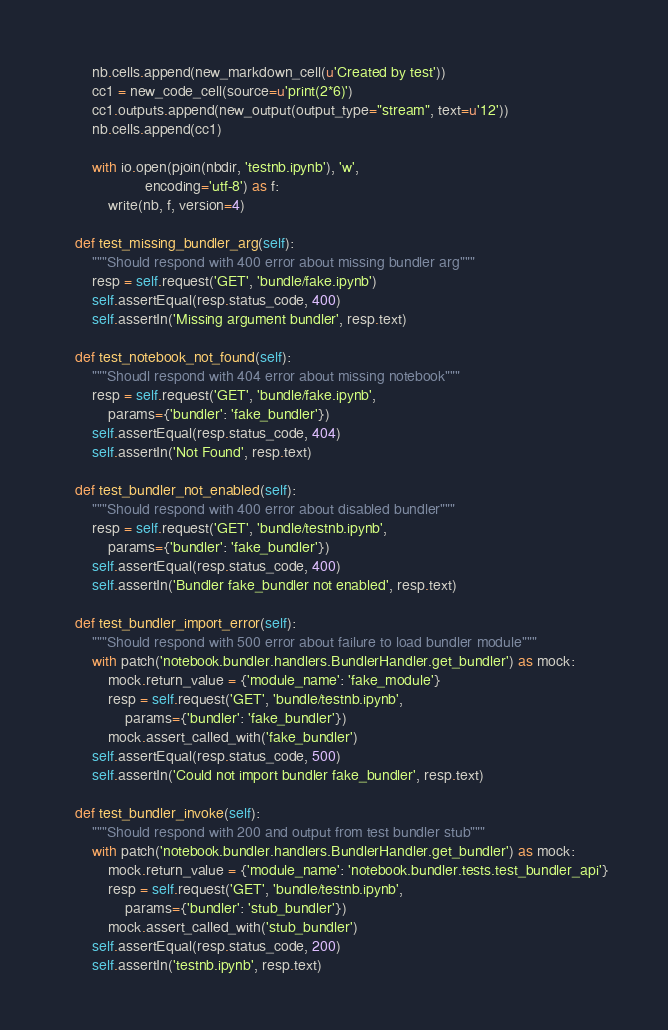Convert code to text. <code><loc_0><loc_0><loc_500><loc_500><_Python_>        nb.cells.append(new_markdown_cell(u'Created by test'))
        cc1 = new_code_cell(source=u'print(2*6)')
        cc1.outputs.append(new_output(output_type="stream", text=u'12'))
        nb.cells.append(cc1)
        
        with io.open(pjoin(nbdir, 'testnb.ipynb'), 'w',
                     encoding='utf-8') as f:
            write(nb, f, version=4)

    def test_missing_bundler_arg(self):
        """Should respond with 400 error about missing bundler arg"""
        resp = self.request('GET', 'bundle/fake.ipynb')
        self.assertEqual(resp.status_code, 400)
        self.assertIn('Missing argument bundler', resp.text)

    def test_notebook_not_found(self):
        """Shoudl respond with 404 error about missing notebook"""
        resp = self.request('GET', 'bundle/fake.ipynb',
            params={'bundler': 'fake_bundler'})
        self.assertEqual(resp.status_code, 404)
        self.assertIn('Not Found', resp.text)

    def test_bundler_not_enabled(self):
        """Should respond with 400 error about disabled bundler"""
        resp = self.request('GET', 'bundle/testnb.ipynb',
            params={'bundler': 'fake_bundler'})
        self.assertEqual(resp.status_code, 400)
        self.assertIn('Bundler fake_bundler not enabled', resp.text)

    def test_bundler_import_error(self):
        """Should respond with 500 error about failure to load bundler module"""
        with patch('notebook.bundler.handlers.BundlerHandler.get_bundler') as mock:
            mock.return_value = {'module_name': 'fake_module'}
            resp = self.request('GET', 'bundle/testnb.ipynb',
                params={'bundler': 'fake_bundler'})
            mock.assert_called_with('fake_bundler')
        self.assertEqual(resp.status_code, 500)
        self.assertIn('Could not import bundler fake_bundler', resp.text)
        
    def test_bundler_invoke(self):
        """Should respond with 200 and output from test bundler stub"""
        with patch('notebook.bundler.handlers.BundlerHandler.get_bundler') as mock:
            mock.return_value = {'module_name': 'notebook.bundler.tests.test_bundler_api'}
            resp = self.request('GET', 'bundle/testnb.ipynb',
                params={'bundler': 'stub_bundler'})
            mock.assert_called_with('stub_bundler')
        self.assertEqual(resp.status_code, 200)
        self.assertIn('testnb.ipynb', resp.text)</code> 